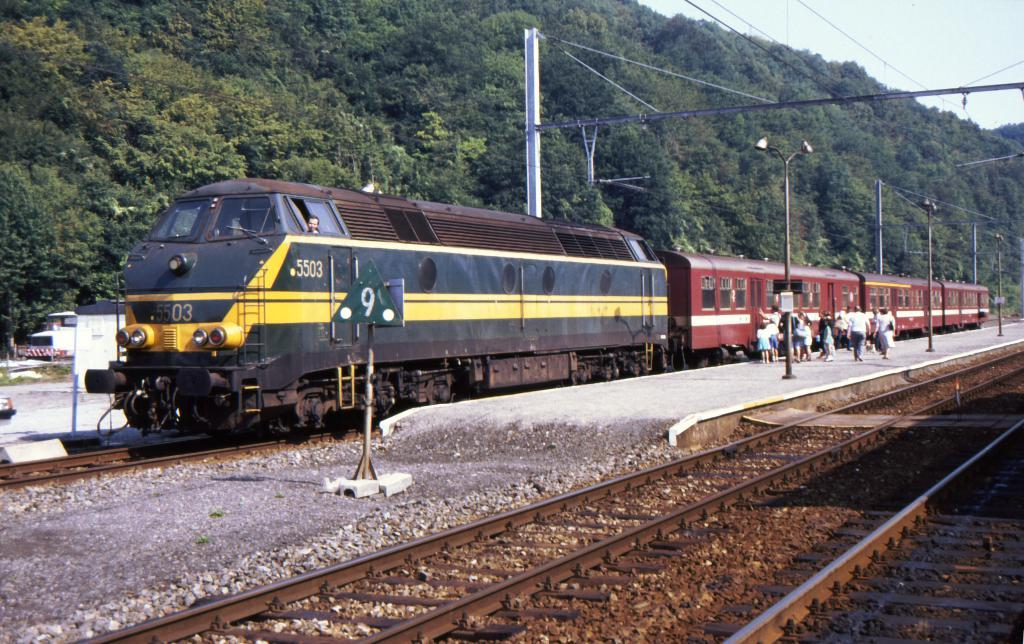<image>
Share a concise interpretation of the image provided. the numbers 5503 which is on a train 